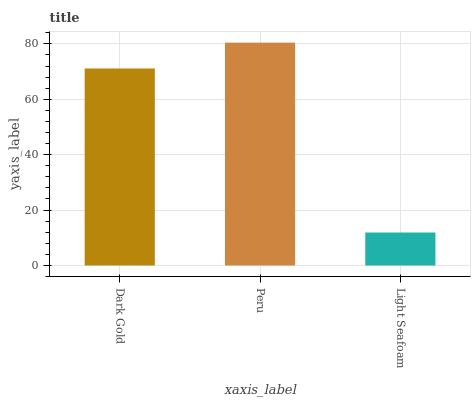Is Light Seafoam the minimum?
Answer yes or no. Yes. Is Peru the maximum?
Answer yes or no. Yes. Is Peru the minimum?
Answer yes or no. No. Is Light Seafoam the maximum?
Answer yes or no. No. Is Peru greater than Light Seafoam?
Answer yes or no. Yes. Is Light Seafoam less than Peru?
Answer yes or no. Yes. Is Light Seafoam greater than Peru?
Answer yes or no. No. Is Peru less than Light Seafoam?
Answer yes or no. No. Is Dark Gold the high median?
Answer yes or no. Yes. Is Dark Gold the low median?
Answer yes or no. Yes. Is Peru the high median?
Answer yes or no. No. Is Peru the low median?
Answer yes or no. No. 